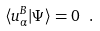<formula> <loc_0><loc_0><loc_500><loc_500>\langle u ^ { B } _ { \alpha } | \Psi \rangle = 0 \ .</formula> 